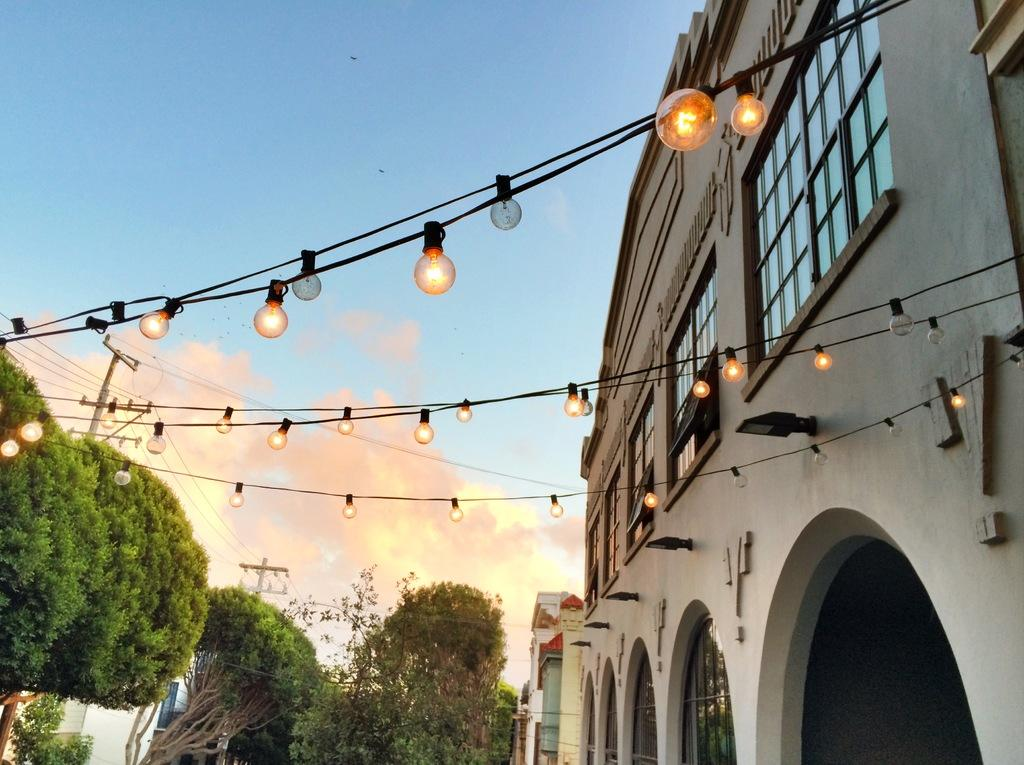What type of structures can be seen in the image? There are buildings in the image. What natural elements are present in the image? There are trees in the image. What man-made objects can be seen in the image? There are poles in the image. What type of lighting is visible in the image? Serial bulbs are visible in the image. How would you describe the sky in the image? The sky is blue and cloudy in the image. How does the scale of the buildings in the image transport the viewer to a different time period? The image does not contain any information about the scale of the buildings or their ability to transport the viewer to a different time period. Additionally, there is no mention of a time period in the image. 